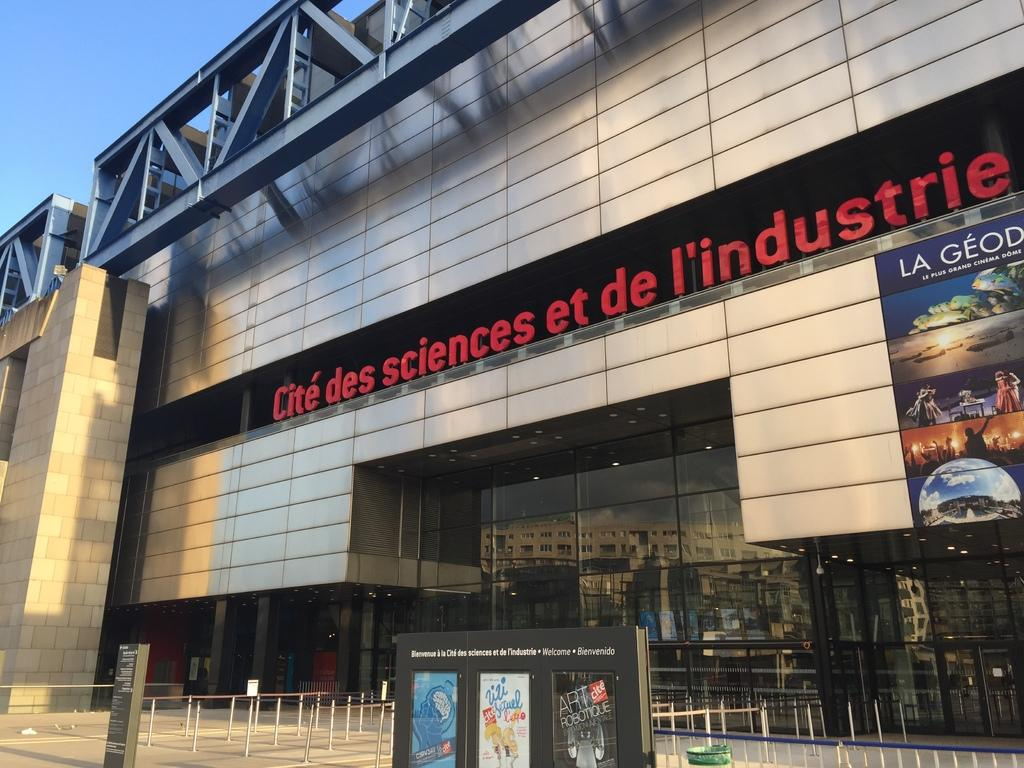<image>
Describe the image concisely. The front entrance of Cité des sciences et de l'industrie. 